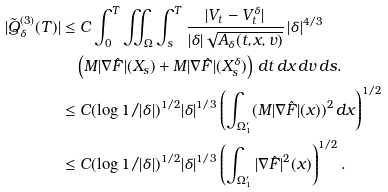<formula> <loc_0><loc_0><loc_500><loc_500>| \tilde { Q } ^ { ( 3 ) } _ { \delta } ( T ) | & \leq C \int _ { 0 } ^ { T } \iint _ { \Omega } \int _ { s } ^ { T } \frac { | V _ { t } - V _ { t } ^ { \delta } | } { | \delta | \sqrt { A _ { \delta } ( t , x , v ) } } \, | \delta | ^ { 4 / 3 } \\ & \quad \left ( M | \nabla \hat { F } | ( X _ { s } ) + M | \nabla \hat { F } | ( X ^ { \delta } _ { s } ) \right ) \, d t \, d x \, d v \, d s . \\ & \leq C ( \log 1 / | \delta | ) ^ { 1 / 2 } | \delta | ^ { 1 / 3 } \left ( \int _ { \Omega ^ { \prime } _ { 1 } } ( M | \nabla \hat { F } | ( x ) ) ^ { 2 } \, d x \right ) ^ { 1 / 2 } \\ & \leq C ( \log 1 / | \delta | ) ^ { 1 / 2 } | \delta | ^ { 1 / 3 } \left ( \int _ { \Omega ^ { \prime } _ { 1 } } | \nabla \hat { F } | ^ { 2 } ( x ) \right ) ^ { 1 / 2 } .</formula> 